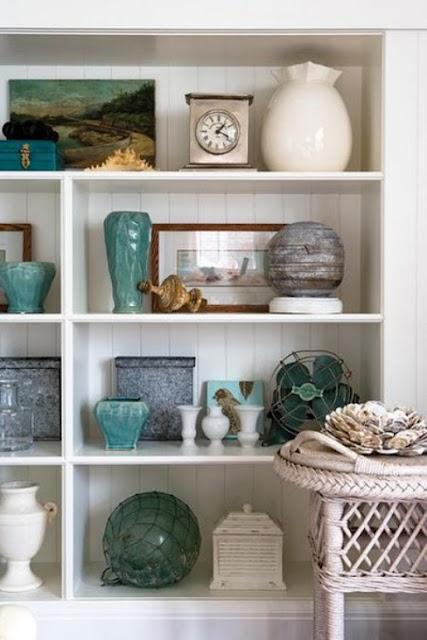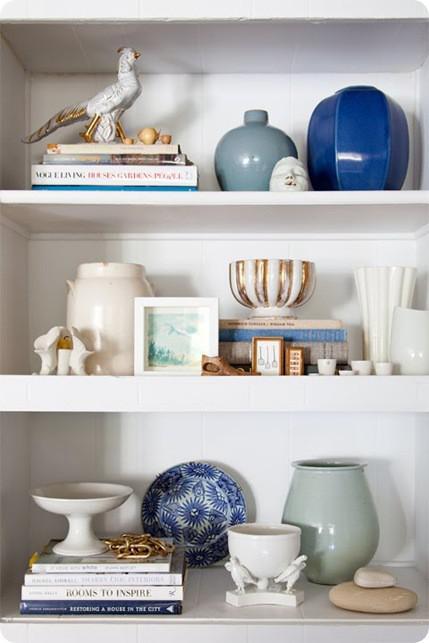The first image is the image on the left, the second image is the image on the right. Examine the images to the left and right. Is the description "There is a clock on the shelf in the image on the left." accurate? Answer yes or no. Yes. 